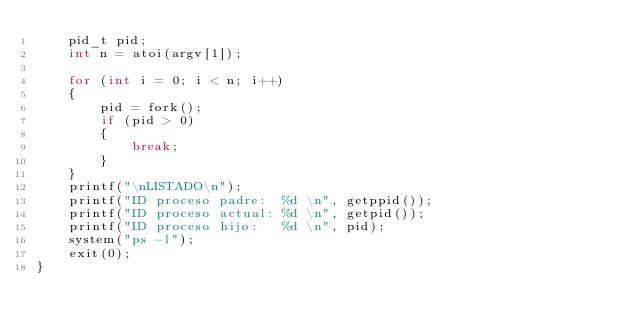<code> <loc_0><loc_0><loc_500><loc_500><_C_>    pid_t pid;
    int n = atoi(argv[1]);

    for (int i = 0; i < n; i++)
    {
        pid = fork();
        if (pid > 0) 
        {
            break;
        }
    }
    printf("\nLISTADO\n");
    printf("ID proceso padre:  %d \n", getppid());
    printf("ID proceso actual: %d \n", getpid());
    printf("ID proceso hijo:   %d \n", pid);
    system("ps -l");
    exit(0);
}</code> 